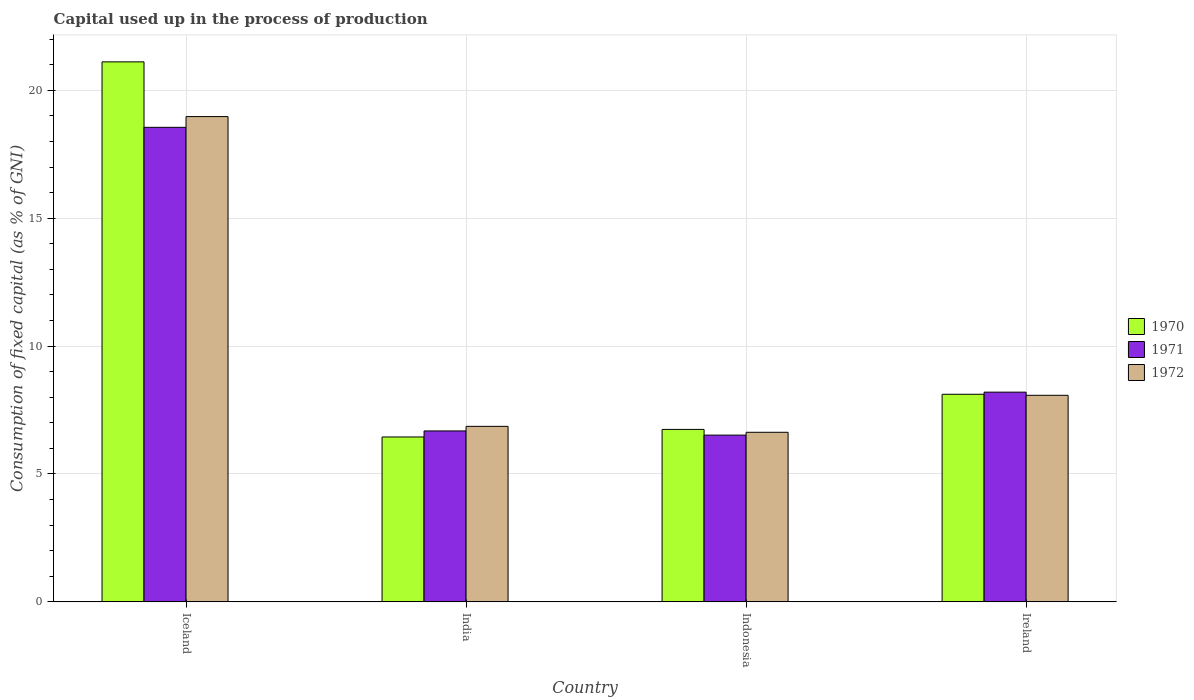How many different coloured bars are there?
Offer a terse response. 3. How many groups of bars are there?
Your answer should be compact. 4. Are the number of bars per tick equal to the number of legend labels?
Keep it short and to the point. Yes. Are the number of bars on each tick of the X-axis equal?
Offer a terse response. Yes. In how many cases, is the number of bars for a given country not equal to the number of legend labels?
Provide a short and direct response. 0. What is the capital used up in the process of production in 1970 in Indonesia?
Provide a short and direct response. 6.74. Across all countries, what is the maximum capital used up in the process of production in 1972?
Your response must be concise. 18.97. Across all countries, what is the minimum capital used up in the process of production in 1972?
Your answer should be very brief. 6.63. What is the total capital used up in the process of production in 1972 in the graph?
Your response must be concise. 40.54. What is the difference between the capital used up in the process of production in 1970 in India and that in Indonesia?
Offer a very short reply. -0.3. What is the difference between the capital used up in the process of production in 1970 in Iceland and the capital used up in the process of production in 1972 in India?
Offer a terse response. 14.25. What is the average capital used up in the process of production in 1971 per country?
Give a very brief answer. 9.99. What is the difference between the capital used up in the process of production of/in 1972 and capital used up in the process of production of/in 1970 in Indonesia?
Your answer should be very brief. -0.11. What is the ratio of the capital used up in the process of production in 1970 in Iceland to that in Ireland?
Give a very brief answer. 2.6. Is the capital used up in the process of production in 1971 in Iceland less than that in Ireland?
Give a very brief answer. No. What is the difference between the highest and the second highest capital used up in the process of production in 1972?
Provide a succinct answer. -10.9. What is the difference between the highest and the lowest capital used up in the process of production in 1970?
Offer a very short reply. 14.67. What does the 3rd bar from the left in India represents?
Make the answer very short. 1972. What does the 1st bar from the right in Iceland represents?
Ensure brevity in your answer.  1972. How many bars are there?
Provide a succinct answer. 12. How many countries are there in the graph?
Your answer should be very brief. 4. Does the graph contain any zero values?
Make the answer very short. No. How many legend labels are there?
Make the answer very short. 3. How are the legend labels stacked?
Give a very brief answer. Vertical. What is the title of the graph?
Your response must be concise. Capital used up in the process of production. What is the label or title of the Y-axis?
Provide a short and direct response. Consumption of fixed capital (as % of GNI). What is the Consumption of fixed capital (as % of GNI) in 1970 in Iceland?
Provide a short and direct response. 21.11. What is the Consumption of fixed capital (as % of GNI) in 1971 in Iceland?
Your answer should be compact. 18.55. What is the Consumption of fixed capital (as % of GNI) of 1972 in Iceland?
Keep it short and to the point. 18.97. What is the Consumption of fixed capital (as % of GNI) of 1970 in India?
Ensure brevity in your answer.  6.45. What is the Consumption of fixed capital (as % of GNI) of 1971 in India?
Your answer should be compact. 6.68. What is the Consumption of fixed capital (as % of GNI) in 1972 in India?
Your answer should be compact. 6.86. What is the Consumption of fixed capital (as % of GNI) in 1970 in Indonesia?
Ensure brevity in your answer.  6.74. What is the Consumption of fixed capital (as % of GNI) of 1971 in Indonesia?
Offer a very short reply. 6.52. What is the Consumption of fixed capital (as % of GNI) of 1972 in Indonesia?
Keep it short and to the point. 6.63. What is the Consumption of fixed capital (as % of GNI) in 1970 in Ireland?
Provide a short and direct response. 8.12. What is the Consumption of fixed capital (as % of GNI) in 1971 in Ireland?
Keep it short and to the point. 8.2. What is the Consumption of fixed capital (as % of GNI) in 1972 in Ireland?
Provide a short and direct response. 8.08. Across all countries, what is the maximum Consumption of fixed capital (as % of GNI) of 1970?
Make the answer very short. 21.11. Across all countries, what is the maximum Consumption of fixed capital (as % of GNI) in 1971?
Your answer should be very brief. 18.55. Across all countries, what is the maximum Consumption of fixed capital (as % of GNI) in 1972?
Your answer should be very brief. 18.97. Across all countries, what is the minimum Consumption of fixed capital (as % of GNI) of 1970?
Provide a succinct answer. 6.45. Across all countries, what is the minimum Consumption of fixed capital (as % of GNI) of 1971?
Offer a terse response. 6.52. Across all countries, what is the minimum Consumption of fixed capital (as % of GNI) in 1972?
Offer a very short reply. 6.63. What is the total Consumption of fixed capital (as % of GNI) in 1970 in the graph?
Your response must be concise. 42.42. What is the total Consumption of fixed capital (as % of GNI) of 1971 in the graph?
Offer a very short reply. 39.96. What is the total Consumption of fixed capital (as % of GNI) of 1972 in the graph?
Make the answer very short. 40.54. What is the difference between the Consumption of fixed capital (as % of GNI) of 1970 in Iceland and that in India?
Make the answer very short. 14.67. What is the difference between the Consumption of fixed capital (as % of GNI) of 1971 in Iceland and that in India?
Offer a very short reply. 11.87. What is the difference between the Consumption of fixed capital (as % of GNI) in 1972 in Iceland and that in India?
Ensure brevity in your answer.  12.11. What is the difference between the Consumption of fixed capital (as % of GNI) of 1970 in Iceland and that in Indonesia?
Your answer should be compact. 14.37. What is the difference between the Consumption of fixed capital (as % of GNI) of 1971 in Iceland and that in Indonesia?
Your response must be concise. 12.03. What is the difference between the Consumption of fixed capital (as % of GNI) in 1972 in Iceland and that in Indonesia?
Offer a very short reply. 12.34. What is the difference between the Consumption of fixed capital (as % of GNI) of 1970 in Iceland and that in Ireland?
Your response must be concise. 13. What is the difference between the Consumption of fixed capital (as % of GNI) in 1971 in Iceland and that in Ireland?
Provide a short and direct response. 10.35. What is the difference between the Consumption of fixed capital (as % of GNI) in 1972 in Iceland and that in Ireland?
Ensure brevity in your answer.  10.9. What is the difference between the Consumption of fixed capital (as % of GNI) in 1970 in India and that in Indonesia?
Your answer should be compact. -0.3. What is the difference between the Consumption of fixed capital (as % of GNI) of 1971 in India and that in Indonesia?
Give a very brief answer. 0.16. What is the difference between the Consumption of fixed capital (as % of GNI) in 1972 in India and that in Indonesia?
Ensure brevity in your answer.  0.23. What is the difference between the Consumption of fixed capital (as % of GNI) in 1970 in India and that in Ireland?
Ensure brevity in your answer.  -1.67. What is the difference between the Consumption of fixed capital (as % of GNI) in 1971 in India and that in Ireland?
Keep it short and to the point. -1.52. What is the difference between the Consumption of fixed capital (as % of GNI) in 1972 in India and that in Ireland?
Offer a very short reply. -1.21. What is the difference between the Consumption of fixed capital (as % of GNI) in 1970 in Indonesia and that in Ireland?
Ensure brevity in your answer.  -1.37. What is the difference between the Consumption of fixed capital (as % of GNI) in 1971 in Indonesia and that in Ireland?
Your response must be concise. -1.68. What is the difference between the Consumption of fixed capital (as % of GNI) in 1972 in Indonesia and that in Ireland?
Offer a terse response. -1.45. What is the difference between the Consumption of fixed capital (as % of GNI) of 1970 in Iceland and the Consumption of fixed capital (as % of GNI) of 1971 in India?
Provide a short and direct response. 14.43. What is the difference between the Consumption of fixed capital (as % of GNI) of 1970 in Iceland and the Consumption of fixed capital (as % of GNI) of 1972 in India?
Your answer should be very brief. 14.25. What is the difference between the Consumption of fixed capital (as % of GNI) in 1971 in Iceland and the Consumption of fixed capital (as % of GNI) in 1972 in India?
Provide a succinct answer. 11.69. What is the difference between the Consumption of fixed capital (as % of GNI) of 1970 in Iceland and the Consumption of fixed capital (as % of GNI) of 1971 in Indonesia?
Offer a very short reply. 14.59. What is the difference between the Consumption of fixed capital (as % of GNI) of 1970 in Iceland and the Consumption of fixed capital (as % of GNI) of 1972 in Indonesia?
Provide a succinct answer. 14.48. What is the difference between the Consumption of fixed capital (as % of GNI) in 1971 in Iceland and the Consumption of fixed capital (as % of GNI) in 1972 in Indonesia?
Offer a very short reply. 11.92. What is the difference between the Consumption of fixed capital (as % of GNI) of 1970 in Iceland and the Consumption of fixed capital (as % of GNI) of 1971 in Ireland?
Keep it short and to the point. 12.91. What is the difference between the Consumption of fixed capital (as % of GNI) in 1970 in Iceland and the Consumption of fixed capital (as % of GNI) in 1972 in Ireland?
Your response must be concise. 13.04. What is the difference between the Consumption of fixed capital (as % of GNI) in 1971 in Iceland and the Consumption of fixed capital (as % of GNI) in 1972 in Ireland?
Provide a succinct answer. 10.48. What is the difference between the Consumption of fixed capital (as % of GNI) in 1970 in India and the Consumption of fixed capital (as % of GNI) in 1971 in Indonesia?
Provide a short and direct response. -0.07. What is the difference between the Consumption of fixed capital (as % of GNI) in 1970 in India and the Consumption of fixed capital (as % of GNI) in 1972 in Indonesia?
Ensure brevity in your answer.  -0.18. What is the difference between the Consumption of fixed capital (as % of GNI) in 1971 in India and the Consumption of fixed capital (as % of GNI) in 1972 in Indonesia?
Ensure brevity in your answer.  0.05. What is the difference between the Consumption of fixed capital (as % of GNI) in 1970 in India and the Consumption of fixed capital (as % of GNI) in 1971 in Ireland?
Make the answer very short. -1.75. What is the difference between the Consumption of fixed capital (as % of GNI) in 1970 in India and the Consumption of fixed capital (as % of GNI) in 1972 in Ireland?
Your answer should be compact. -1.63. What is the difference between the Consumption of fixed capital (as % of GNI) of 1971 in India and the Consumption of fixed capital (as % of GNI) of 1972 in Ireland?
Offer a very short reply. -1.39. What is the difference between the Consumption of fixed capital (as % of GNI) in 1970 in Indonesia and the Consumption of fixed capital (as % of GNI) in 1971 in Ireland?
Your answer should be compact. -1.46. What is the difference between the Consumption of fixed capital (as % of GNI) of 1970 in Indonesia and the Consumption of fixed capital (as % of GNI) of 1972 in Ireland?
Give a very brief answer. -1.33. What is the difference between the Consumption of fixed capital (as % of GNI) of 1971 in Indonesia and the Consumption of fixed capital (as % of GNI) of 1972 in Ireland?
Give a very brief answer. -1.56. What is the average Consumption of fixed capital (as % of GNI) of 1970 per country?
Offer a terse response. 10.6. What is the average Consumption of fixed capital (as % of GNI) of 1971 per country?
Offer a very short reply. 9.99. What is the average Consumption of fixed capital (as % of GNI) of 1972 per country?
Your response must be concise. 10.14. What is the difference between the Consumption of fixed capital (as % of GNI) in 1970 and Consumption of fixed capital (as % of GNI) in 1971 in Iceland?
Your answer should be compact. 2.56. What is the difference between the Consumption of fixed capital (as % of GNI) of 1970 and Consumption of fixed capital (as % of GNI) of 1972 in Iceland?
Offer a terse response. 2.14. What is the difference between the Consumption of fixed capital (as % of GNI) of 1971 and Consumption of fixed capital (as % of GNI) of 1972 in Iceland?
Provide a short and direct response. -0.42. What is the difference between the Consumption of fixed capital (as % of GNI) in 1970 and Consumption of fixed capital (as % of GNI) in 1971 in India?
Your answer should be compact. -0.24. What is the difference between the Consumption of fixed capital (as % of GNI) of 1970 and Consumption of fixed capital (as % of GNI) of 1972 in India?
Your answer should be compact. -0.42. What is the difference between the Consumption of fixed capital (as % of GNI) of 1971 and Consumption of fixed capital (as % of GNI) of 1972 in India?
Provide a succinct answer. -0.18. What is the difference between the Consumption of fixed capital (as % of GNI) of 1970 and Consumption of fixed capital (as % of GNI) of 1971 in Indonesia?
Your answer should be very brief. 0.22. What is the difference between the Consumption of fixed capital (as % of GNI) of 1970 and Consumption of fixed capital (as % of GNI) of 1972 in Indonesia?
Give a very brief answer. 0.11. What is the difference between the Consumption of fixed capital (as % of GNI) of 1971 and Consumption of fixed capital (as % of GNI) of 1972 in Indonesia?
Your answer should be very brief. -0.11. What is the difference between the Consumption of fixed capital (as % of GNI) of 1970 and Consumption of fixed capital (as % of GNI) of 1971 in Ireland?
Provide a short and direct response. -0.08. What is the difference between the Consumption of fixed capital (as % of GNI) in 1970 and Consumption of fixed capital (as % of GNI) in 1972 in Ireland?
Your answer should be very brief. 0.04. What is the difference between the Consumption of fixed capital (as % of GNI) of 1971 and Consumption of fixed capital (as % of GNI) of 1972 in Ireland?
Your response must be concise. 0.12. What is the ratio of the Consumption of fixed capital (as % of GNI) of 1970 in Iceland to that in India?
Provide a succinct answer. 3.27. What is the ratio of the Consumption of fixed capital (as % of GNI) in 1971 in Iceland to that in India?
Keep it short and to the point. 2.78. What is the ratio of the Consumption of fixed capital (as % of GNI) in 1972 in Iceland to that in India?
Ensure brevity in your answer.  2.76. What is the ratio of the Consumption of fixed capital (as % of GNI) in 1970 in Iceland to that in Indonesia?
Your response must be concise. 3.13. What is the ratio of the Consumption of fixed capital (as % of GNI) of 1971 in Iceland to that in Indonesia?
Your answer should be compact. 2.85. What is the ratio of the Consumption of fixed capital (as % of GNI) of 1972 in Iceland to that in Indonesia?
Make the answer very short. 2.86. What is the ratio of the Consumption of fixed capital (as % of GNI) of 1970 in Iceland to that in Ireland?
Your answer should be compact. 2.6. What is the ratio of the Consumption of fixed capital (as % of GNI) of 1971 in Iceland to that in Ireland?
Provide a succinct answer. 2.26. What is the ratio of the Consumption of fixed capital (as % of GNI) of 1972 in Iceland to that in Ireland?
Ensure brevity in your answer.  2.35. What is the ratio of the Consumption of fixed capital (as % of GNI) of 1970 in India to that in Indonesia?
Your response must be concise. 0.96. What is the ratio of the Consumption of fixed capital (as % of GNI) in 1971 in India to that in Indonesia?
Provide a succinct answer. 1.03. What is the ratio of the Consumption of fixed capital (as % of GNI) in 1972 in India to that in Indonesia?
Provide a short and direct response. 1.03. What is the ratio of the Consumption of fixed capital (as % of GNI) of 1970 in India to that in Ireland?
Make the answer very short. 0.79. What is the ratio of the Consumption of fixed capital (as % of GNI) in 1971 in India to that in Ireland?
Your response must be concise. 0.81. What is the ratio of the Consumption of fixed capital (as % of GNI) in 1972 in India to that in Ireland?
Offer a very short reply. 0.85. What is the ratio of the Consumption of fixed capital (as % of GNI) in 1970 in Indonesia to that in Ireland?
Your response must be concise. 0.83. What is the ratio of the Consumption of fixed capital (as % of GNI) of 1971 in Indonesia to that in Ireland?
Offer a very short reply. 0.8. What is the ratio of the Consumption of fixed capital (as % of GNI) of 1972 in Indonesia to that in Ireland?
Offer a terse response. 0.82. What is the difference between the highest and the second highest Consumption of fixed capital (as % of GNI) in 1970?
Your answer should be compact. 13. What is the difference between the highest and the second highest Consumption of fixed capital (as % of GNI) of 1971?
Give a very brief answer. 10.35. What is the difference between the highest and the second highest Consumption of fixed capital (as % of GNI) in 1972?
Ensure brevity in your answer.  10.9. What is the difference between the highest and the lowest Consumption of fixed capital (as % of GNI) in 1970?
Give a very brief answer. 14.67. What is the difference between the highest and the lowest Consumption of fixed capital (as % of GNI) of 1971?
Your answer should be compact. 12.03. What is the difference between the highest and the lowest Consumption of fixed capital (as % of GNI) of 1972?
Offer a terse response. 12.34. 